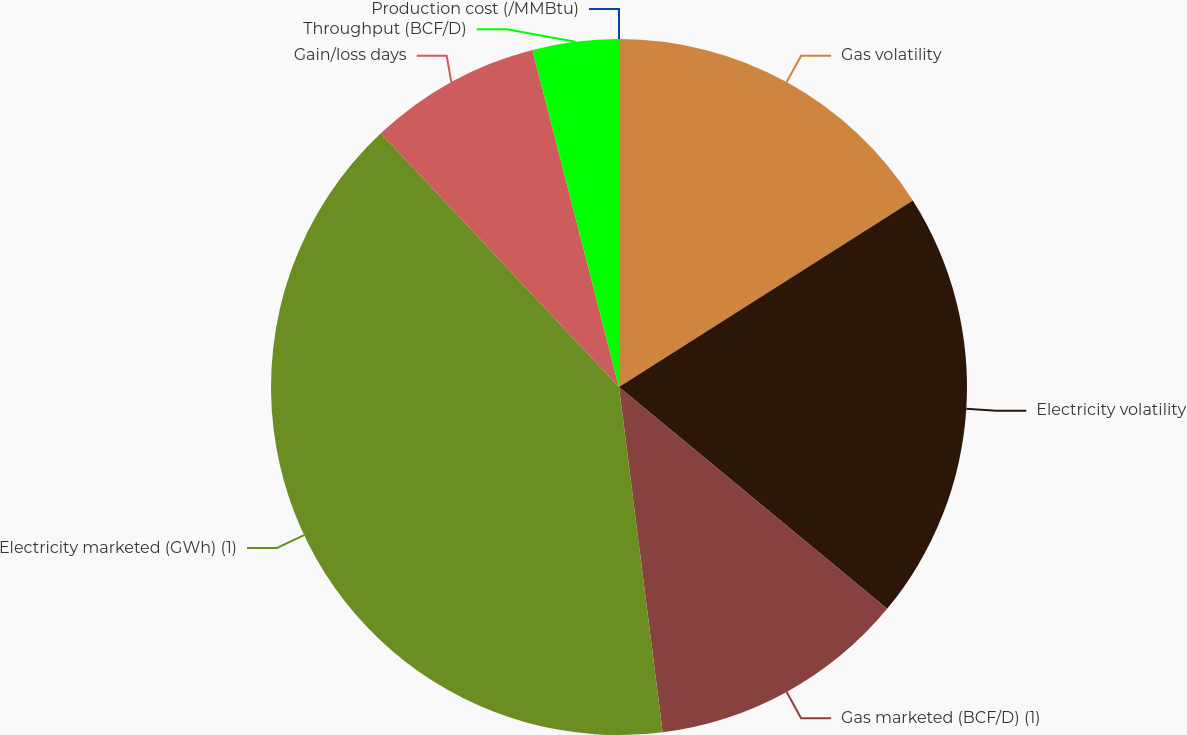Convert chart. <chart><loc_0><loc_0><loc_500><loc_500><pie_chart><fcel>Gas volatility<fcel>Electricity volatility<fcel>Gas marketed (BCF/D) (1)<fcel>Electricity marketed (GWh) (1)<fcel>Gain/loss days<fcel>Throughput (BCF/D)<fcel>Production cost (/MMBtu)<nl><fcel>16.0%<fcel>20.0%<fcel>12.0%<fcel>40.0%<fcel>8.0%<fcel>4.0%<fcel>0.0%<nl></chart> 